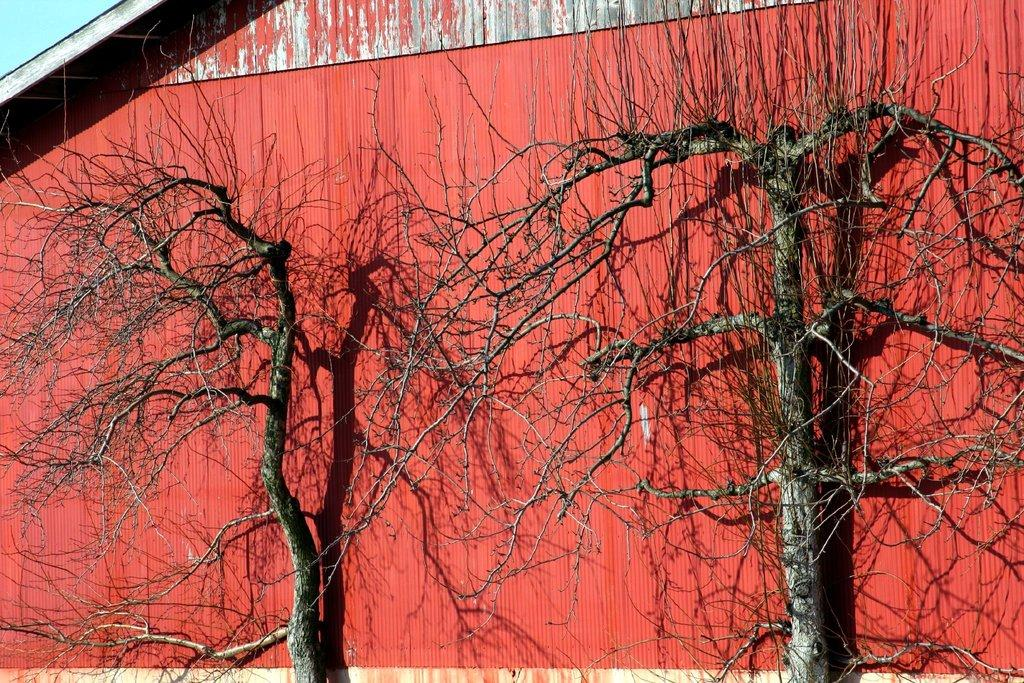What type of vegetation can be seen in the image? There are trees in the image. What type of structure is present in the image? There is a shed in the image. What is the condition of the sky in the image? The sky is clear in the image. Can you see a tiger hiding behind the shed in the image? There is no tiger present in the image; only trees and a shed are visible. What type of nut is being used to secure the shed in the image? There is no mention of nuts or any fastening mechanism for the shed in the image. 